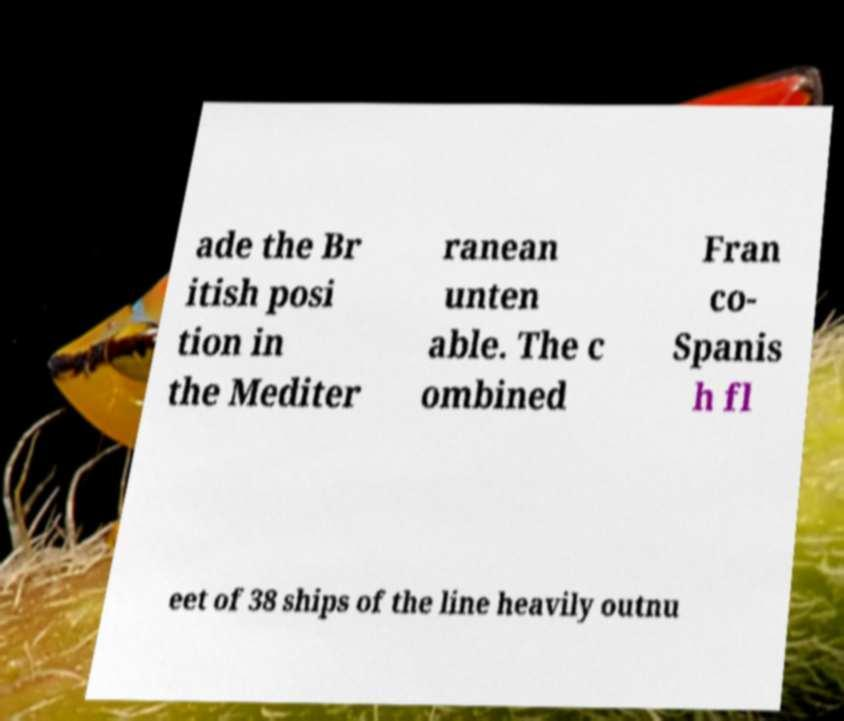Could you extract and type out the text from this image? ade the Br itish posi tion in the Mediter ranean unten able. The c ombined Fran co- Spanis h fl eet of 38 ships of the line heavily outnu 